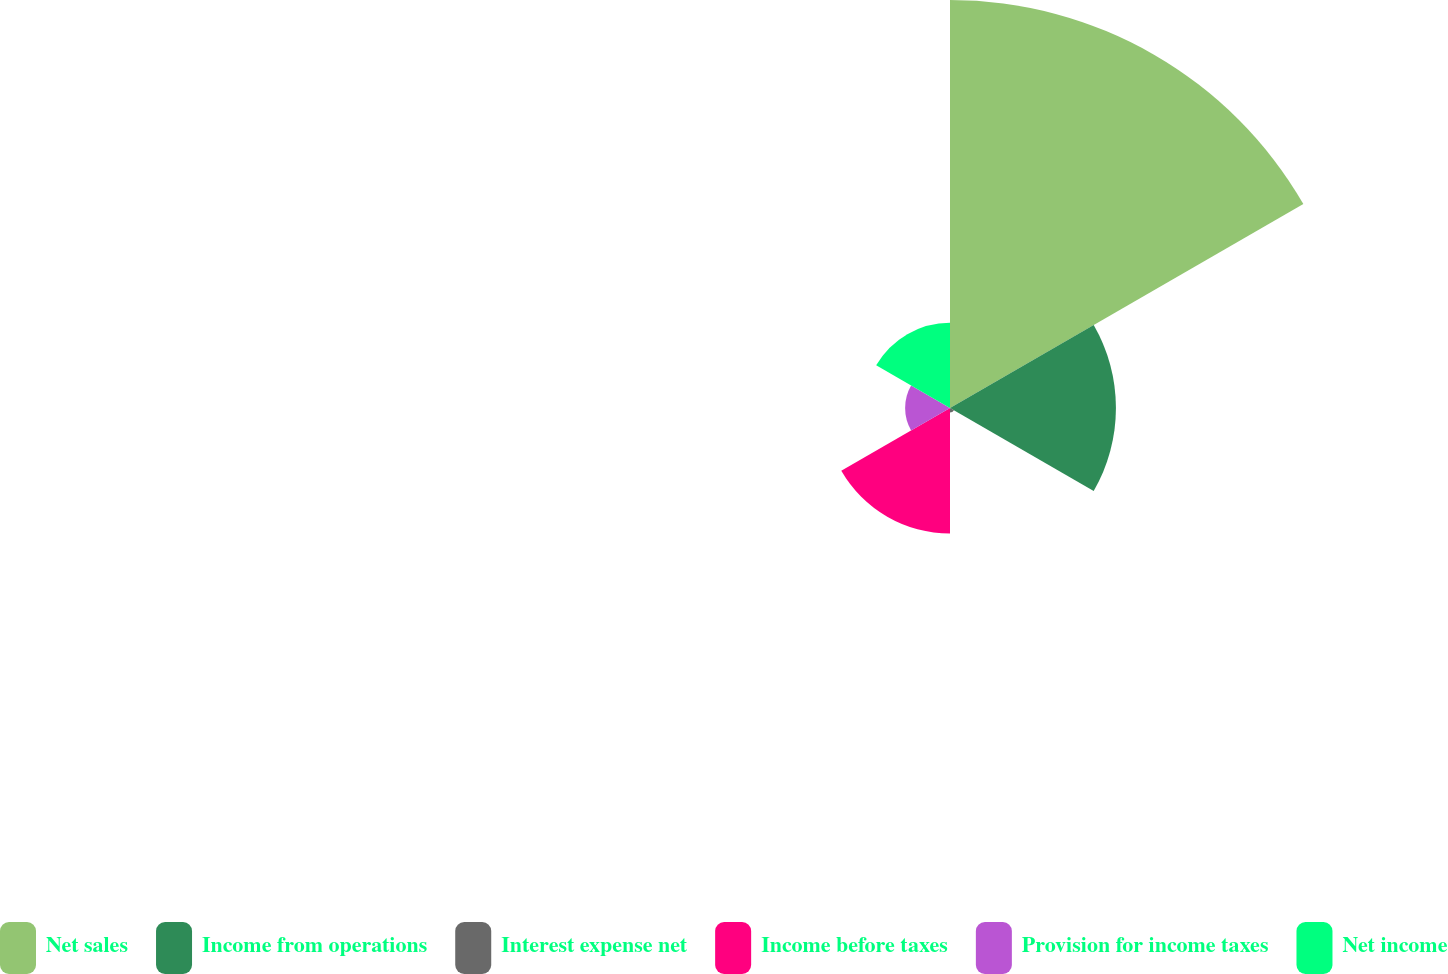<chart> <loc_0><loc_0><loc_500><loc_500><pie_chart><fcel>Net sales<fcel>Income from operations<fcel>Interest expense net<fcel>Income before taxes<fcel>Provision for income taxes<fcel>Net income<nl><fcel>48.91%<fcel>19.89%<fcel>0.55%<fcel>15.05%<fcel>5.38%<fcel>10.22%<nl></chart> 